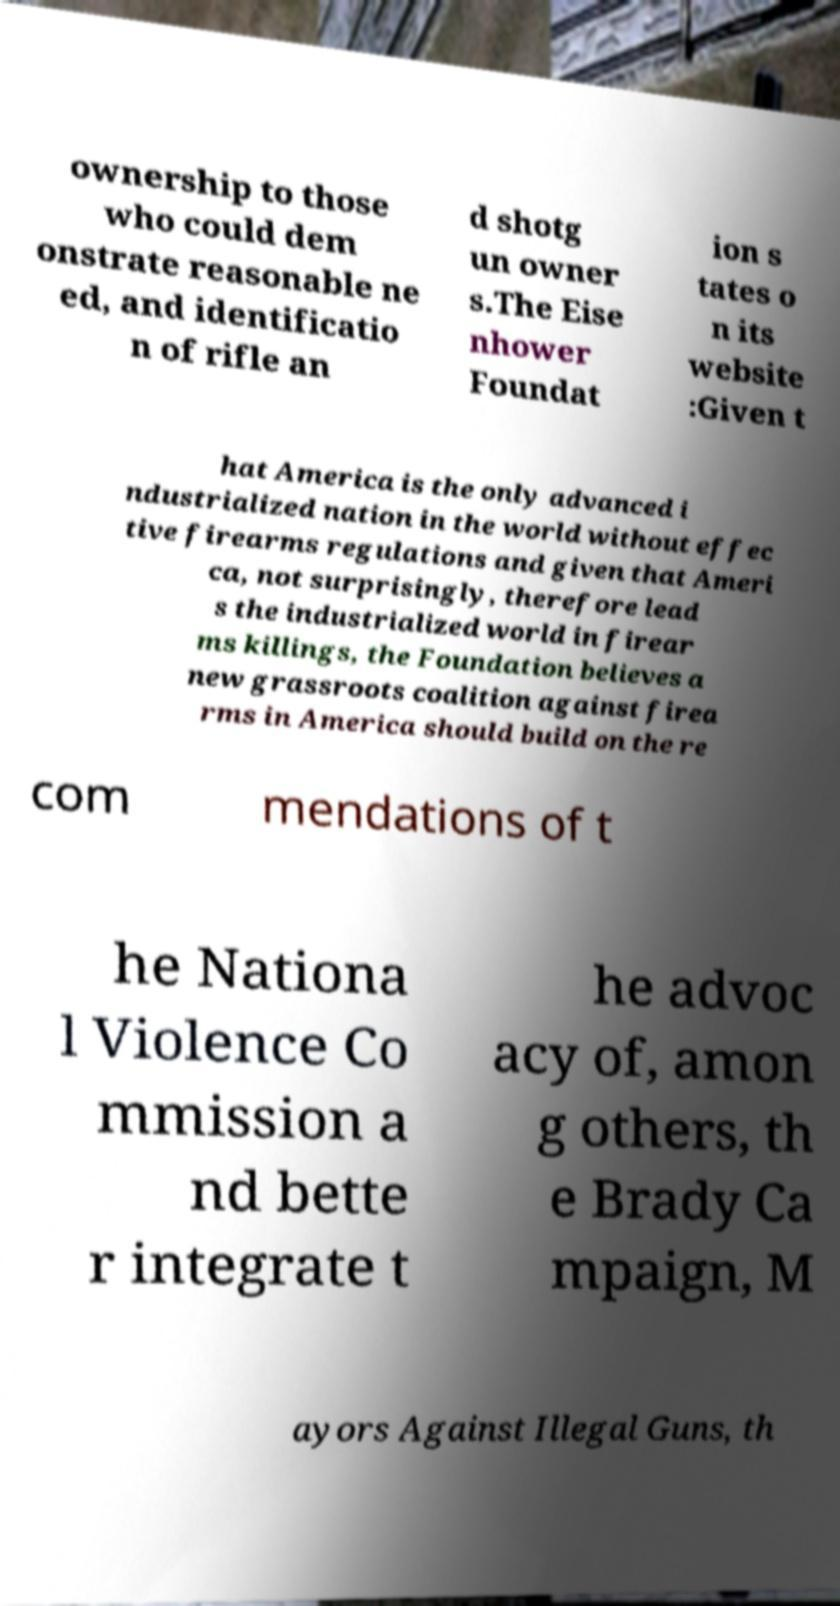Could you extract and type out the text from this image? ownership to those who could dem onstrate reasonable ne ed, and identificatio n of rifle an d shotg un owner s.The Eise nhower Foundat ion s tates o n its website :Given t hat America is the only advanced i ndustrialized nation in the world without effec tive firearms regulations and given that Ameri ca, not surprisingly, therefore lead s the industrialized world in firear ms killings, the Foundation believes a new grassroots coalition against firea rms in America should build on the re com mendations of t he Nationa l Violence Co mmission a nd bette r integrate t he advoc acy of, amon g others, th e Brady Ca mpaign, M ayors Against Illegal Guns, th 